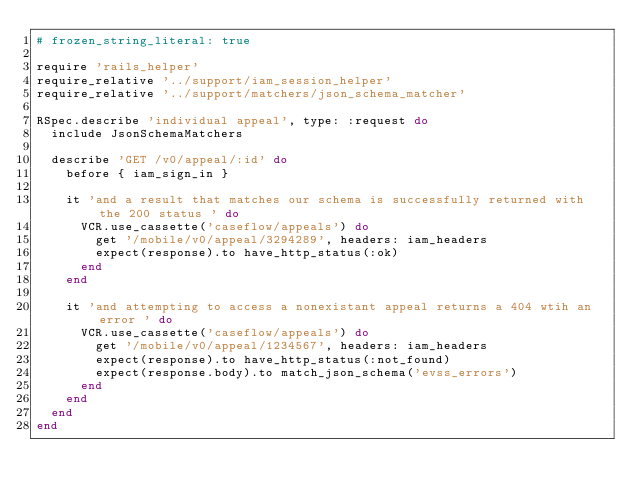<code> <loc_0><loc_0><loc_500><loc_500><_Ruby_># frozen_string_literal: true

require 'rails_helper'
require_relative '../support/iam_session_helper'
require_relative '../support/matchers/json_schema_matcher'

RSpec.describe 'individual appeal', type: :request do
  include JsonSchemaMatchers

  describe 'GET /v0/appeal/:id' do
    before { iam_sign_in }

    it 'and a result that matches our schema is successfully returned with the 200 status ' do
      VCR.use_cassette('caseflow/appeals') do
        get '/mobile/v0/appeal/3294289', headers: iam_headers
        expect(response).to have_http_status(:ok)
      end
    end

    it 'and attempting to access a nonexistant appeal returns a 404 wtih an error ' do
      VCR.use_cassette('caseflow/appeals') do
        get '/mobile/v0/appeal/1234567', headers: iam_headers
        expect(response).to have_http_status(:not_found)
        expect(response.body).to match_json_schema('evss_errors')
      end
    end
  end
end
</code> 